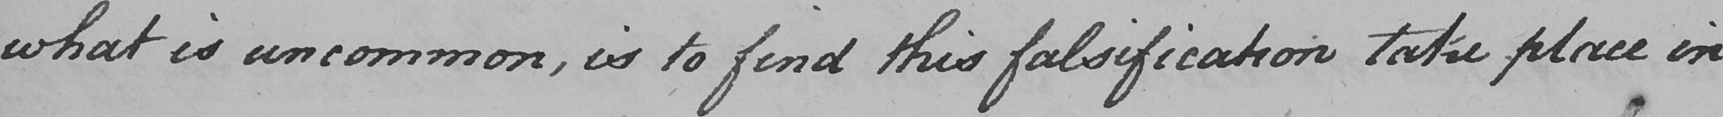Can you tell me what this handwritten text says? what is uncommon , is to find this falsification take place in 